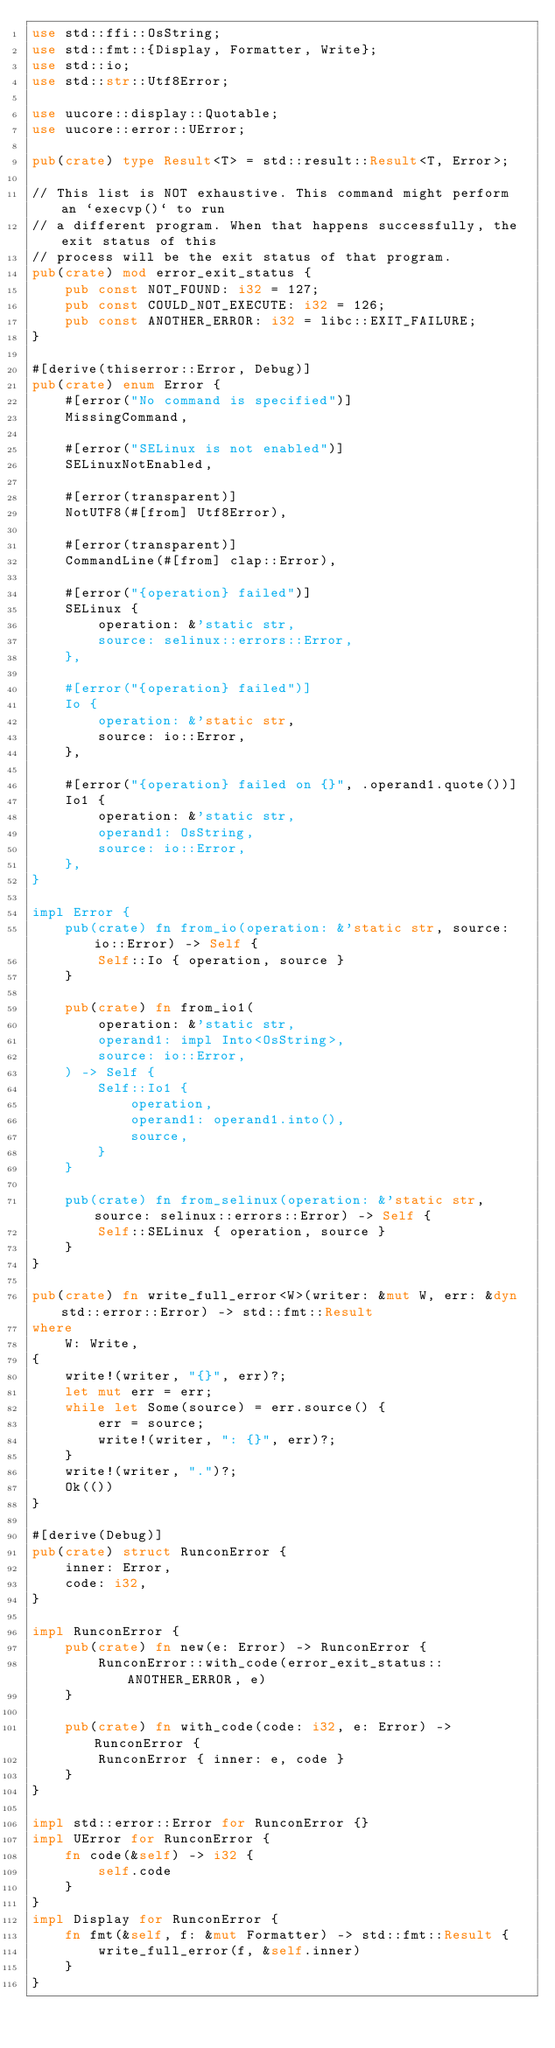Convert code to text. <code><loc_0><loc_0><loc_500><loc_500><_Rust_>use std::ffi::OsString;
use std::fmt::{Display, Formatter, Write};
use std::io;
use std::str::Utf8Error;

use uucore::display::Quotable;
use uucore::error::UError;

pub(crate) type Result<T> = std::result::Result<T, Error>;

// This list is NOT exhaustive. This command might perform an `execvp()` to run
// a different program. When that happens successfully, the exit status of this
// process will be the exit status of that program.
pub(crate) mod error_exit_status {
    pub const NOT_FOUND: i32 = 127;
    pub const COULD_NOT_EXECUTE: i32 = 126;
    pub const ANOTHER_ERROR: i32 = libc::EXIT_FAILURE;
}

#[derive(thiserror::Error, Debug)]
pub(crate) enum Error {
    #[error("No command is specified")]
    MissingCommand,

    #[error("SELinux is not enabled")]
    SELinuxNotEnabled,

    #[error(transparent)]
    NotUTF8(#[from] Utf8Error),

    #[error(transparent)]
    CommandLine(#[from] clap::Error),

    #[error("{operation} failed")]
    SELinux {
        operation: &'static str,
        source: selinux::errors::Error,
    },

    #[error("{operation} failed")]
    Io {
        operation: &'static str,
        source: io::Error,
    },

    #[error("{operation} failed on {}", .operand1.quote())]
    Io1 {
        operation: &'static str,
        operand1: OsString,
        source: io::Error,
    },
}

impl Error {
    pub(crate) fn from_io(operation: &'static str, source: io::Error) -> Self {
        Self::Io { operation, source }
    }

    pub(crate) fn from_io1(
        operation: &'static str,
        operand1: impl Into<OsString>,
        source: io::Error,
    ) -> Self {
        Self::Io1 {
            operation,
            operand1: operand1.into(),
            source,
        }
    }

    pub(crate) fn from_selinux(operation: &'static str, source: selinux::errors::Error) -> Self {
        Self::SELinux { operation, source }
    }
}

pub(crate) fn write_full_error<W>(writer: &mut W, err: &dyn std::error::Error) -> std::fmt::Result
where
    W: Write,
{
    write!(writer, "{}", err)?;
    let mut err = err;
    while let Some(source) = err.source() {
        err = source;
        write!(writer, ": {}", err)?;
    }
    write!(writer, ".")?;
    Ok(())
}

#[derive(Debug)]
pub(crate) struct RunconError {
    inner: Error,
    code: i32,
}

impl RunconError {
    pub(crate) fn new(e: Error) -> RunconError {
        RunconError::with_code(error_exit_status::ANOTHER_ERROR, e)
    }

    pub(crate) fn with_code(code: i32, e: Error) -> RunconError {
        RunconError { inner: e, code }
    }
}

impl std::error::Error for RunconError {}
impl UError for RunconError {
    fn code(&self) -> i32 {
        self.code
    }
}
impl Display for RunconError {
    fn fmt(&self, f: &mut Formatter) -> std::fmt::Result {
        write_full_error(f, &self.inner)
    }
}
</code> 